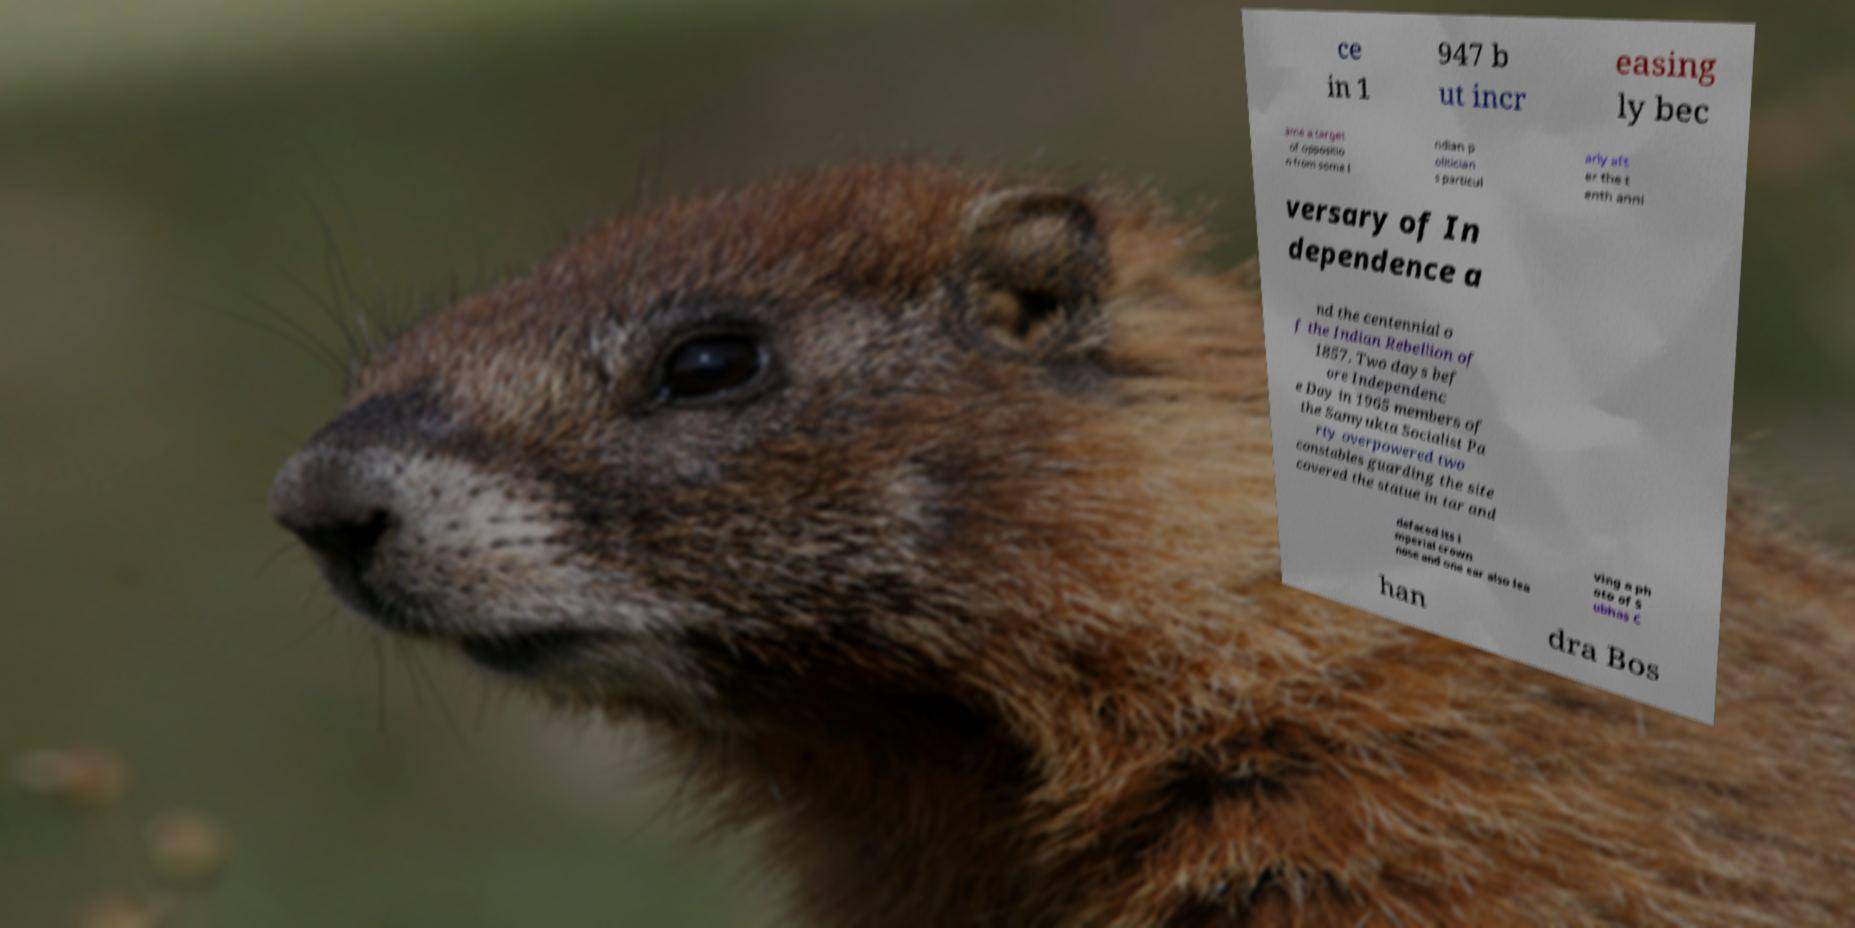For documentation purposes, I need the text within this image transcribed. Could you provide that? ce in 1 947 b ut incr easing ly bec ame a target of oppositio n from some I ndian p olitician s particul arly aft er the t enth anni versary of In dependence a nd the centennial o f the Indian Rebellion of 1857. Two days bef ore Independenc e Day in 1965 members of the Samyukta Socialist Pa rty overpowered two constables guarding the site covered the statue in tar and defaced its i mperial crown nose and one ear also lea ving a ph oto of S ubhas C han dra Bos 